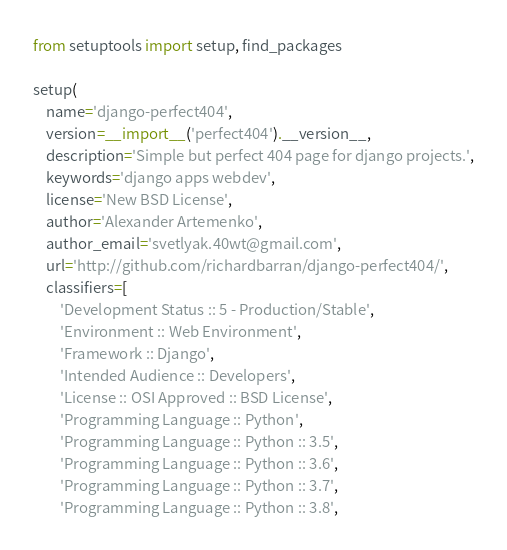Convert code to text. <code><loc_0><loc_0><loc_500><loc_500><_Python_>from setuptools import setup, find_packages

setup(
    name='django-perfect404',
    version=__import__('perfect404').__version__,
    description='Simple but perfect 404 page for django projects.',
    keywords='django apps webdev',
    license='New BSD License',
    author='Alexander Artemenko',
    author_email='svetlyak.40wt@gmail.com',
    url='http://github.com/richardbarran/django-perfect404/',
    classifiers=[
        'Development Status :: 5 - Production/Stable',
        'Environment :: Web Environment',
        'Framework :: Django',
        'Intended Audience :: Developers',
        'License :: OSI Approved :: BSD License',
        'Programming Language :: Python',
        'Programming Language :: Python :: 3.5',
        'Programming Language :: Python :: 3.6',
        'Programming Language :: Python :: 3.7',
        'Programming Language :: Python :: 3.8',</code> 